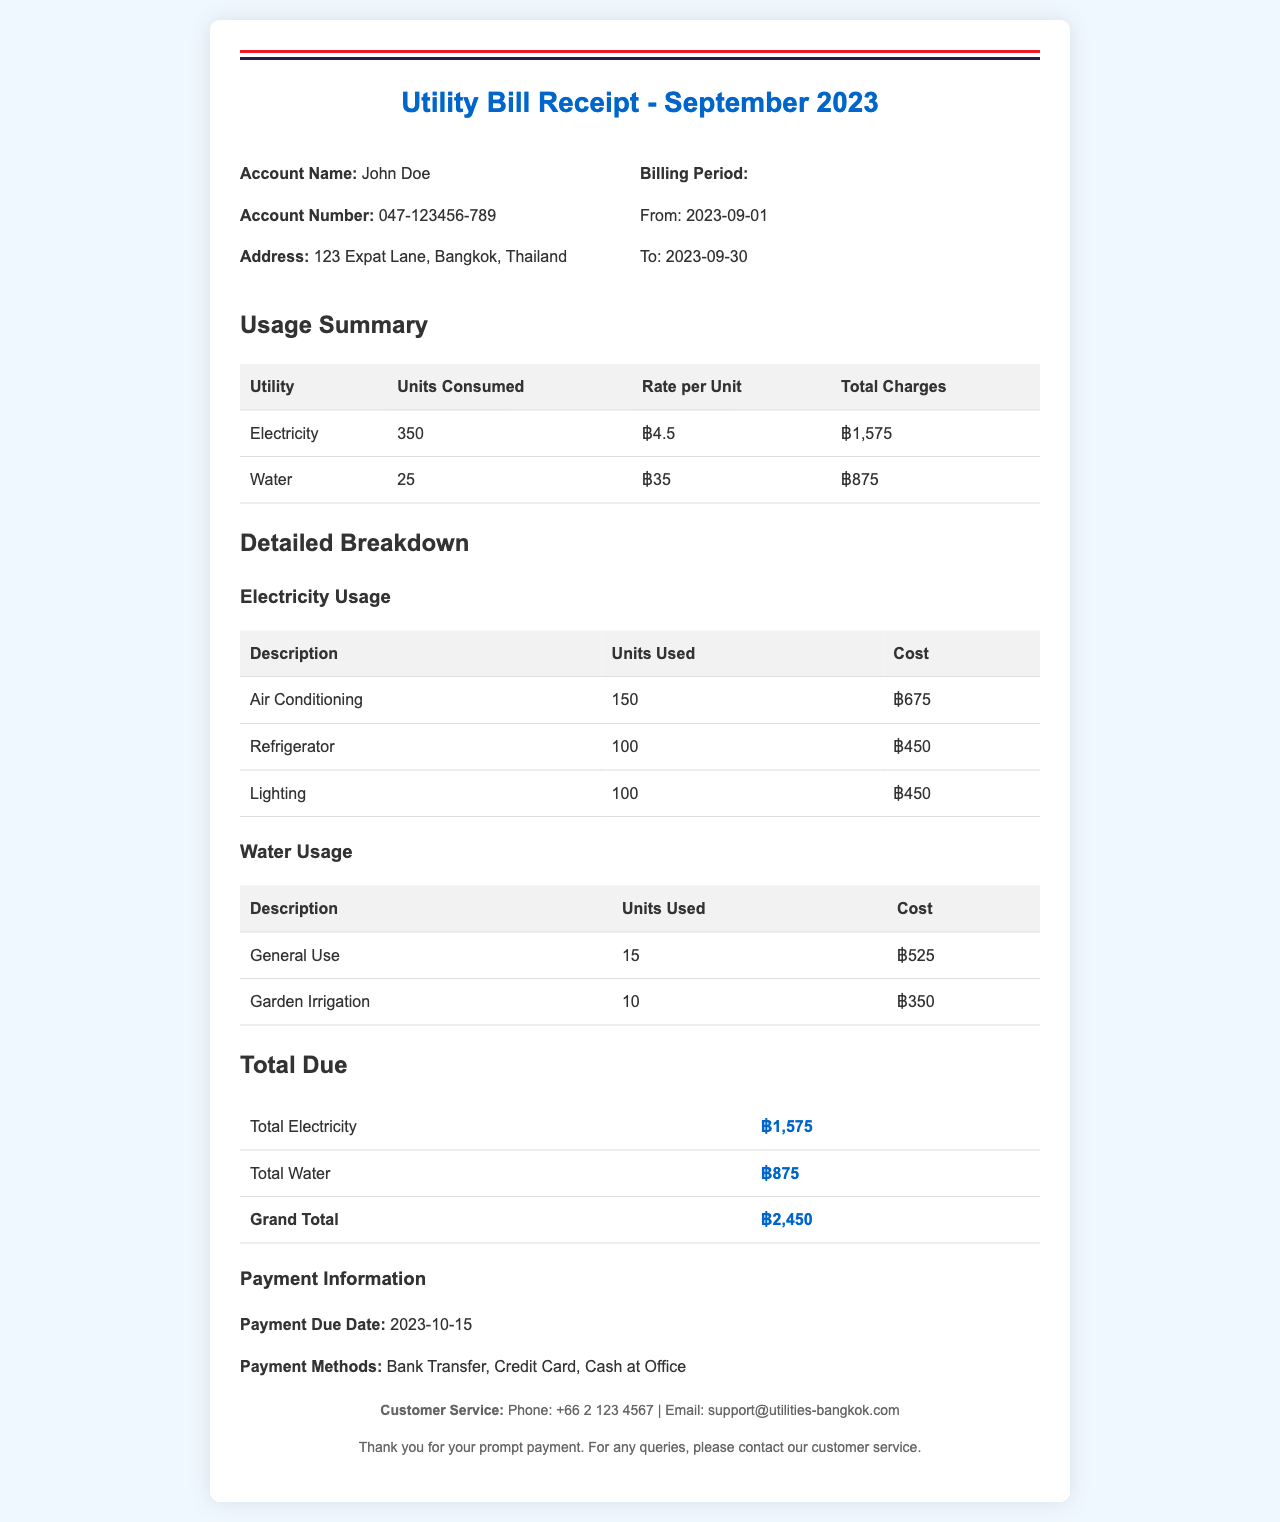What is the account name? The account name is specified at the top of the document under account information.
Answer: John Doe What is the total electricity charge? The total electricity charge is calculated based on electricity usage in the usage summary table.
Answer: ฿1,575 How many units of water were consumed? The total units of water consumed is detailed in the usage summary section of the document.
Answer: 25 What are the payment methods available? Payment methods are listed in the payment information section of the document.
Answer: Bank Transfer, Credit Card, Cash at Office What is the payment due date? The payment due date is mentioned in the payment information section of the document.
Answer: 2023-10-15 How many units were used for air conditioning? Air conditioning usage is detailed in the electricity breakdown section of the document.
Answer: 150 What is the grand total amount due? The grand total is calculated by summing both electricity and water charges in the total due section.
Answer: ฿2,450 What is the rate per unit for water? The rate for water is indicated in the usage summary table.
Answer: ฿35 What is the address listed for the account? The address is provided in the account information section of the document.
Answer: 123 Expat Lane, Bangkok, Thailand 